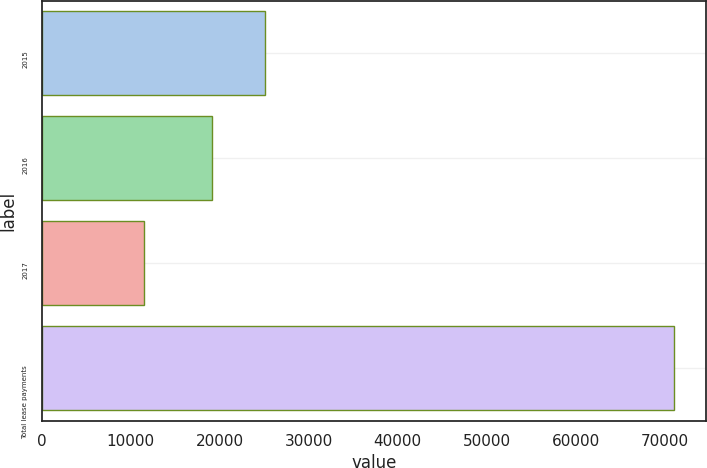<chart> <loc_0><loc_0><loc_500><loc_500><bar_chart><fcel>2015<fcel>2016<fcel>2017<fcel>Total lease payments<nl><fcel>25140<fcel>19165<fcel>11468<fcel>71062<nl></chart> 